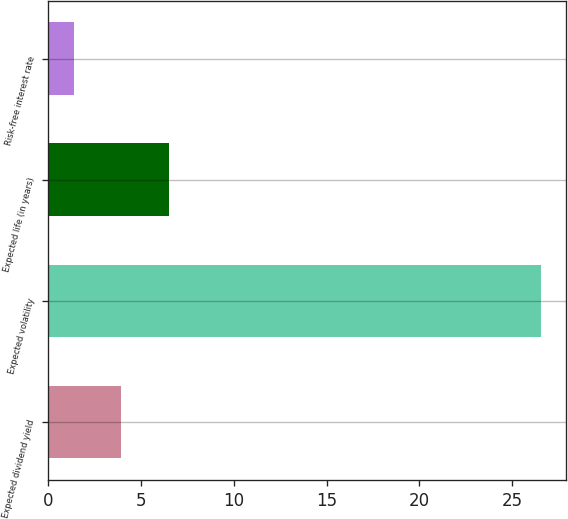Convert chart. <chart><loc_0><loc_0><loc_500><loc_500><bar_chart><fcel>Expected dividend yield<fcel>Expected volatility<fcel>Expected life (in years)<fcel>Risk-free interest rate<nl><fcel>3.91<fcel>26.57<fcel>6.5<fcel>1.39<nl></chart> 